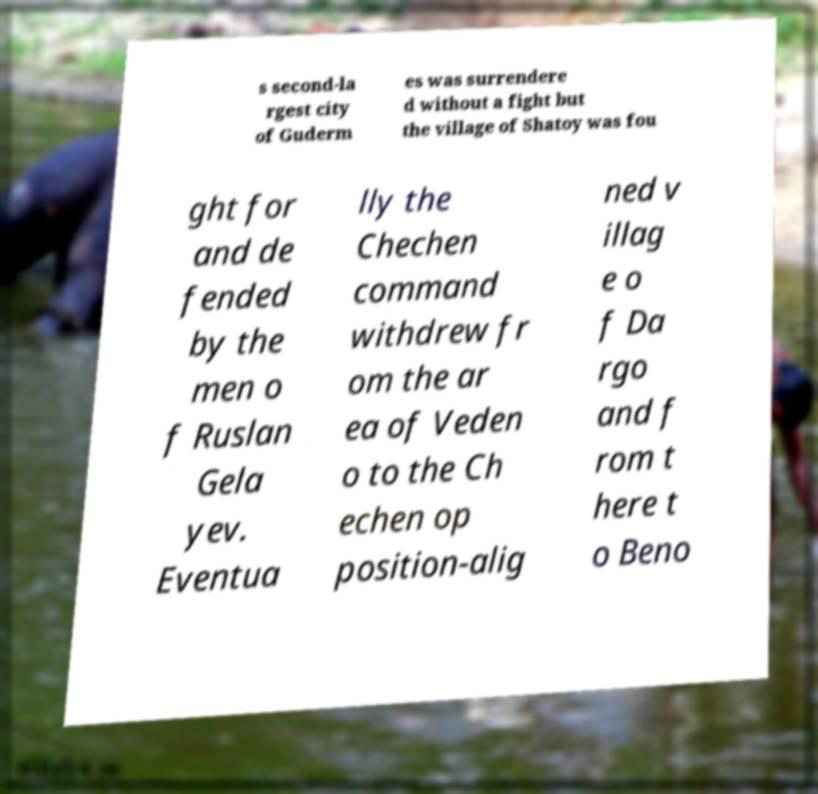For documentation purposes, I need the text within this image transcribed. Could you provide that? s second-la rgest city of Guderm es was surrendere d without a fight but the village of Shatoy was fou ght for and de fended by the men o f Ruslan Gela yev. Eventua lly the Chechen command withdrew fr om the ar ea of Veden o to the Ch echen op position-alig ned v illag e o f Da rgo and f rom t here t o Beno 